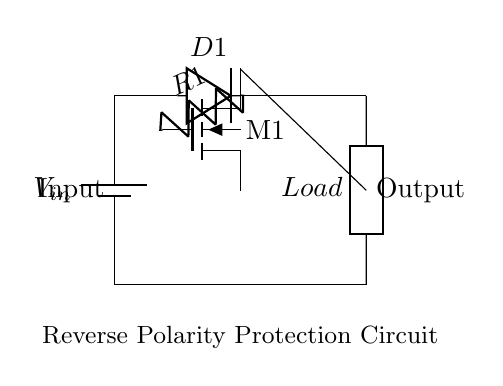What component is used for reverse polarity protection? The component used for reverse polarity protection is the diode, labeled D1 in the circuit. It allows current to flow in one direction, protecting the circuit from damage due to reversed input voltage.
Answer: Diode What is the function of the MOSFET in this circuit? The MOSFET, labeled M1, serves as a switch that controls the current flow to the load. It can be turned on or off based on the voltage polarity, providing additional protection against reverse polarity.
Answer: Switch How many resistors are present in the circuit? There is one resistor in the circuit, labeled R1. It is connected between the gate of the MOSFET and the diode.
Answer: One What is the input voltage symbol in the circuit? The input voltage symbol in the circuit is V_in, labeled next to the battery. This indicates the source voltage applied to the circuit.
Answer: V_in What connection is between the diode and the load? The connection between the diode and the load is a direct line, showing that the diode connects the output to the load, allowing current to flow if the input is correctly polarized.
Answer: Direct What happens if the input voltage is reversed? If the input voltage is reversed, the diode D1 will block the current, preventing it from reaching the load and protecting the circuit from damage.
Answer: Block current 